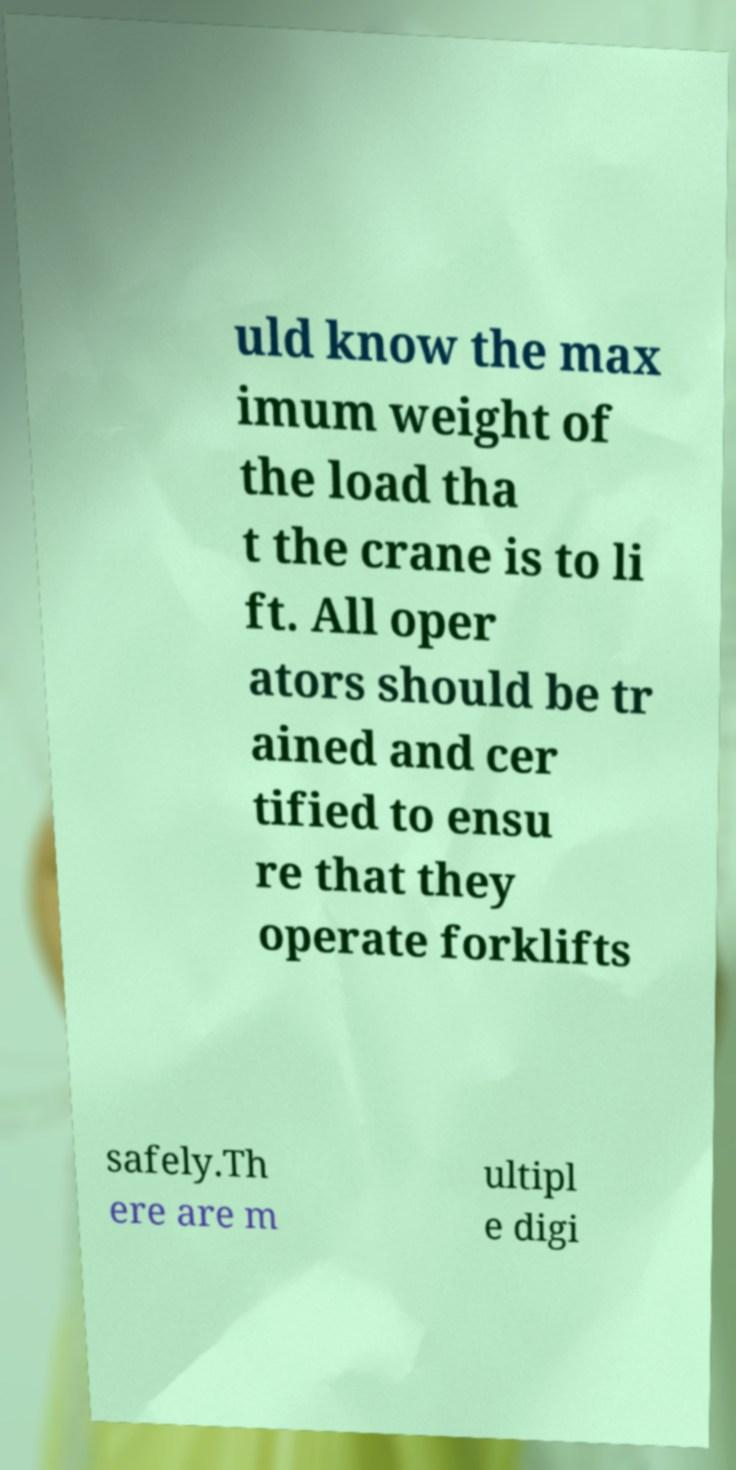Can you accurately transcribe the text from the provided image for me? uld know the max imum weight of the load tha t the crane is to li ft. All oper ators should be tr ained and cer tified to ensu re that they operate forklifts safely.Th ere are m ultipl e digi 